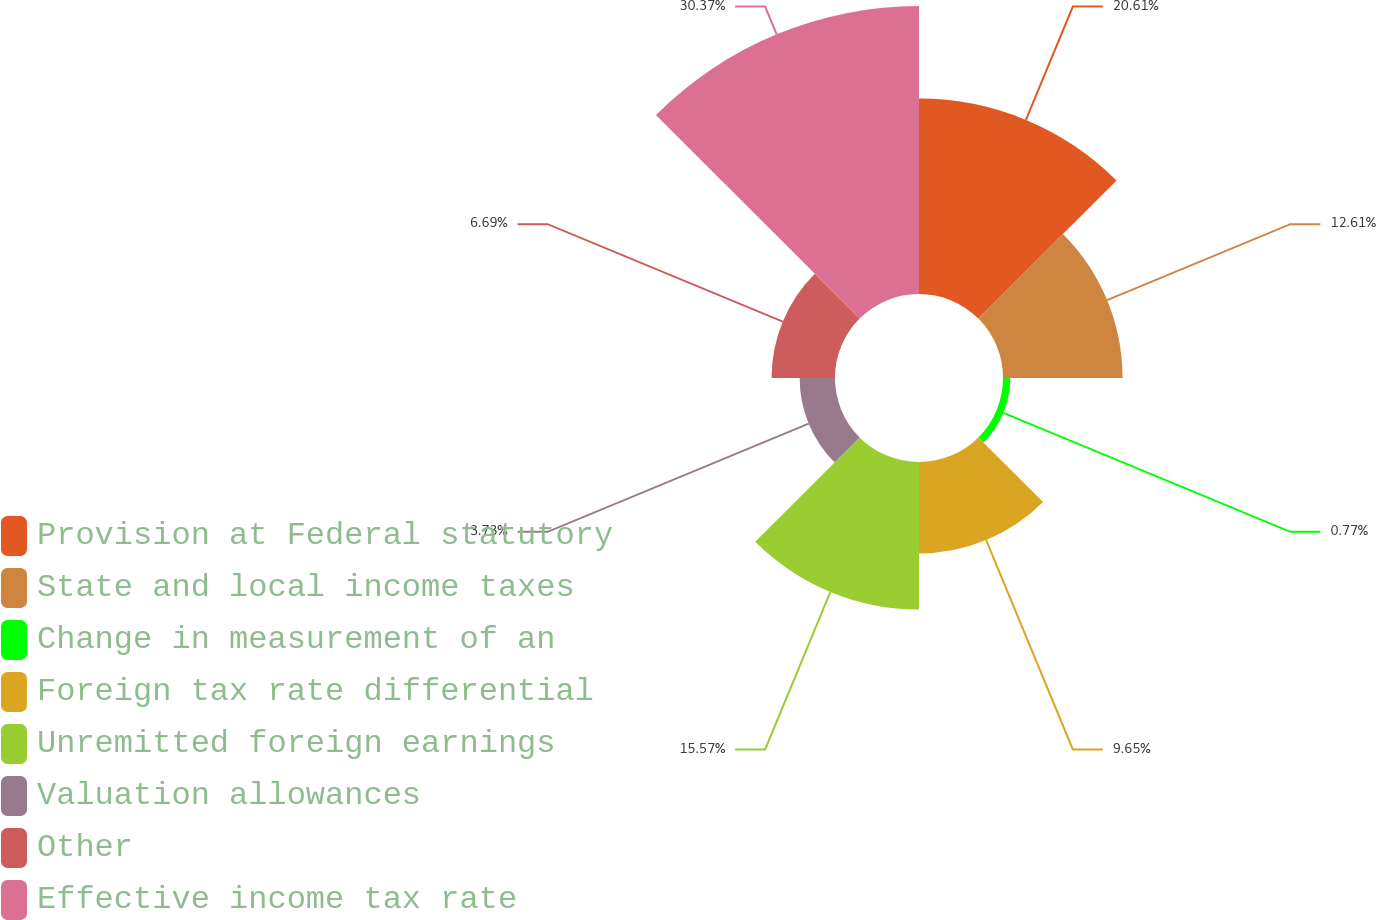Convert chart. <chart><loc_0><loc_0><loc_500><loc_500><pie_chart><fcel>Provision at Federal statutory<fcel>State and local income taxes<fcel>Change in measurement of an<fcel>Foreign tax rate differential<fcel>Unremitted foreign earnings<fcel>Valuation allowances<fcel>Other<fcel>Effective income tax rate<nl><fcel>20.61%<fcel>12.61%<fcel>0.77%<fcel>9.65%<fcel>15.57%<fcel>3.73%<fcel>6.69%<fcel>30.38%<nl></chart> 